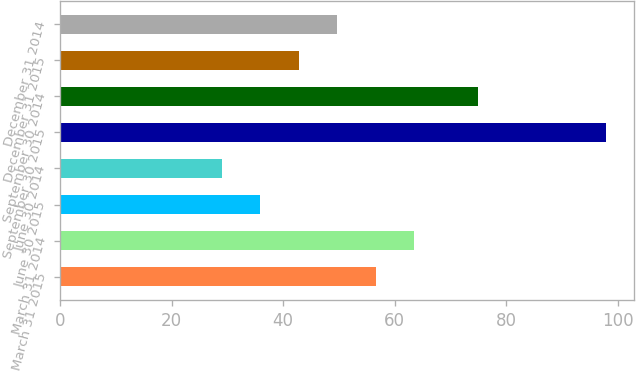Convert chart. <chart><loc_0><loc_0><loc_500><loc_500><bar_chart><fcel>March 31 2015<fcel>March 31 2014<fcel>June 30 2015<fcel>June 30 2014<fcel>September 30 2015<fcel>September 30 2014<fcel>December 31 2015<fcel>December 31 2014<nl><fcel>56.6<fcel>63.5<fcel>35.9<fcel>29<fcel>98<fcel>75<fcel>42.8<fcel>49.7<nl></chart> 